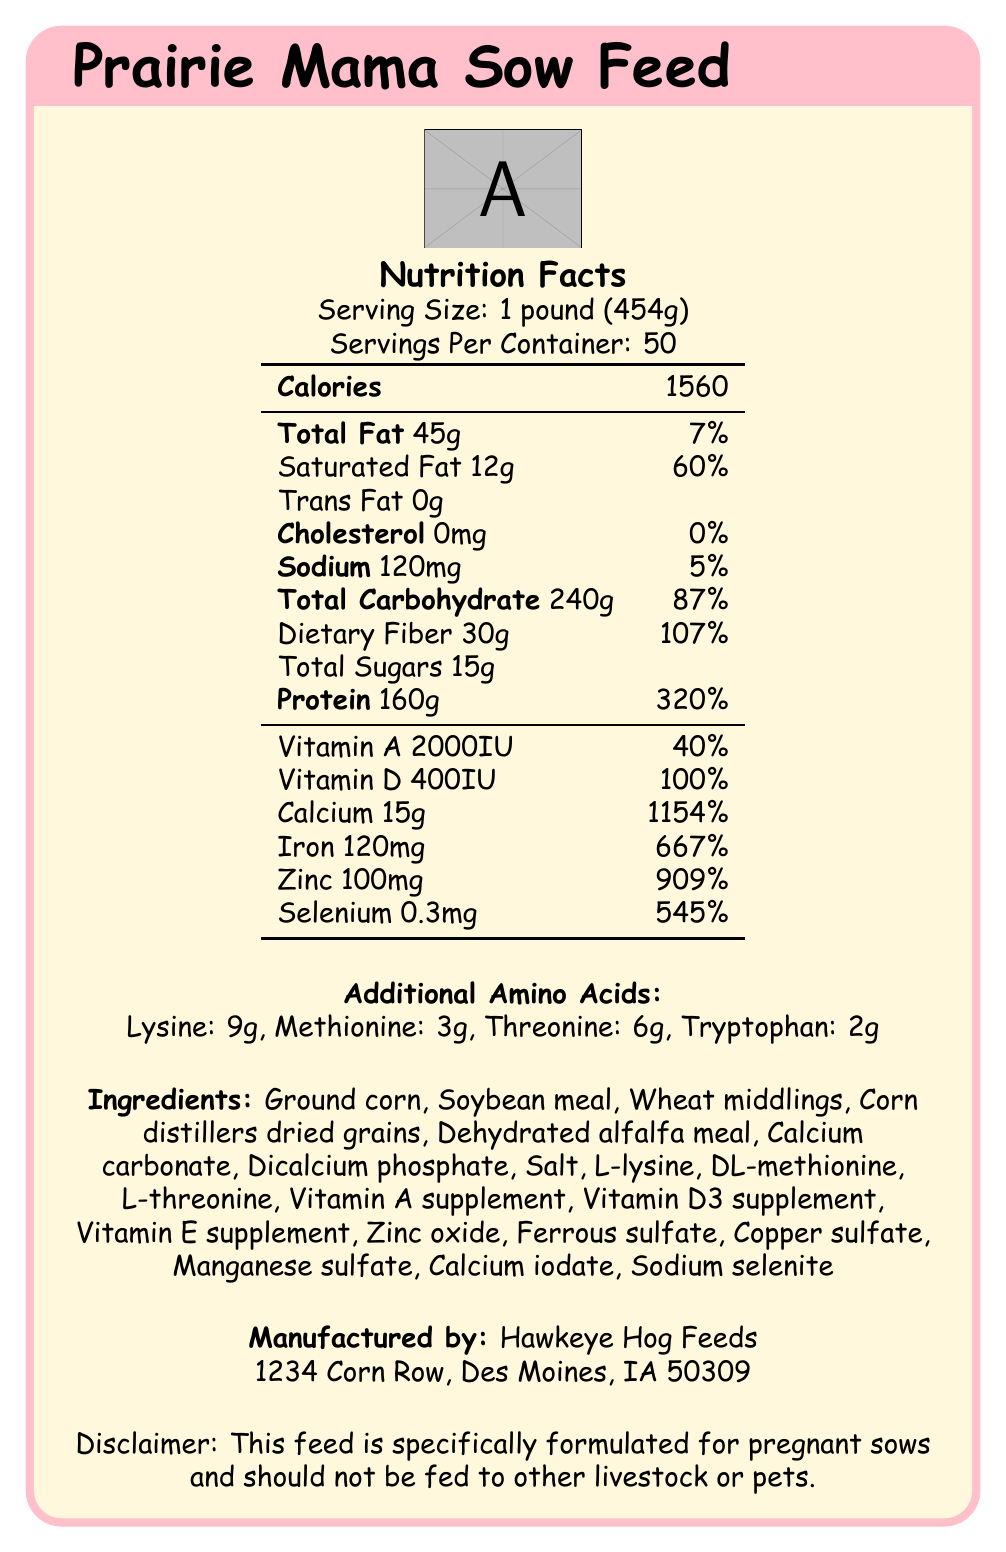what is the serving size? The serving size is mentioned as "1 pound (454g)" in the nutrition facts label.
Answer: 1 pound (454g) how many servings are there per container? The document specifies that there are 50 servings per container.
Answer: 50 how many calories are there per serving? The nutrition facts label lists 1560 calories per serving.
Answer: 1560 what is the total fat content per serving? The total fat content per serving is shown as 45g.
Answer: 45g what is the percentage of daily value for saturated fat? The daily value percentage for saturated fat is listed as 60%.
Answer: 60% how much sodium does the feed contain per serving? The sodium content per serving is 120mg, as stated on the label.
Answer: 120mg how much dietary fiber is there per serving? The dietary fiber per serving is 30g.
Answer: 30g what is the total carbohydrate content per serving? The total carbohydrate content is listed as 240g per serving.
Answer: 240g how much protein does the feed provide per serving? The protein content per serving is stated as 160g.
Answer: 160g what is the daily value percentage for calcium? The daily value percentage for calcium is given as 1154%.
Answer: 1154% which ingredient is not part of the feed formulation? A. Ground corn B. Dehydrated alfalfa meal C. Fish meal D. Soybean meal The ingredient list includes Ground corn, Dehydrated alfalfa meal, and Soybean meal but does not mention Fish meal.
Answer: C. Fish meal how many grams of lysine are present in each serving? A. 3g B. 6g C. 9g D. 12g The label lists lysine content as 9g per serving.
Answer: C. 9g are there any trans fats in the Prairie Mama Sow Feed? The label clearly states that the trans fat content is 0g.
Answer: No is this feed suitable for livestock other than pregnant sows? The disclaimer states the feed is specifically formulated for pregnant sows and should not be fed to other livestock or pets.
Answer: No how much iron does the feed contain, and what is its daily value percentage? The iron content is 120mg per serving, with a daily value percentage of 667%.
Answer: 120mg, 667% where is the manufacturer located? The manufacturer's address is listed as "1234 Corn Row, Des Moines, IA 50309".
Answer: Des Moines, IA what is the main purpose of the Prairie Mama Sow Feed? The disclaimer and overall nutritional content indicate that this feed is designed to meet the specific nutritional needs of pregnant sows.
Answer: To provide nutrition specifically formulated for pregnant sows how much methionine does the feed contain? The label specifies that there are 3g of methionine per serving.
Answer: 3g does the feed contain any Vitamin E? The label does not provide specific information about the content of Vitamin E.
Answer: Not enough information summarize the main points covered in the Prairie Mama Sow Feed nutrition facts label. The document provides detailed nutritional information, serving size, and ingredients list for the Prairie Mama Sow Feed. It emphasizes that the feed is specifically designed for pregnant sows, with a high content of essential nutrients to support their dietary needs. The manufacturer details and disclaimer about appropriate usage are also included.
Answer: The Prairie Mama Sow Feed is a nutritional feed specially formulated for pregnant sows. It contains 1560 calories per pound, along with a detailed breakdown of macronutrients and micronutrients, including high protein and fiber. The feed includes various vitamins and minerals with high daily values, such as calcium, iron, and zinc. Additional amino acids like lysine, methionine, threonine, and tryptophan are also present. Manufactured by Hawkeye Hog Feeds in Des Moines, IA, the feed should not be used for other livestock or pets. 